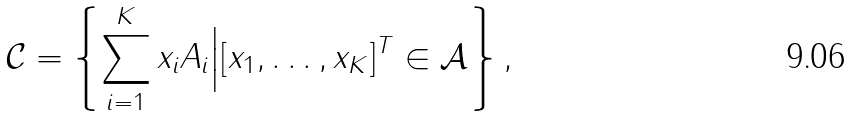<formula> <loc_0><loc_0><loc_500><loc_500>\mathcal { C } = \left \{ \sum _ { i = 1 } ^ { K } { x _ { i } A _ { i } } \Big | [ x _ { 1 } , \dots , x _ { K } ] ^ { T } \in \mathcal { A } \right \} ,</formula> 